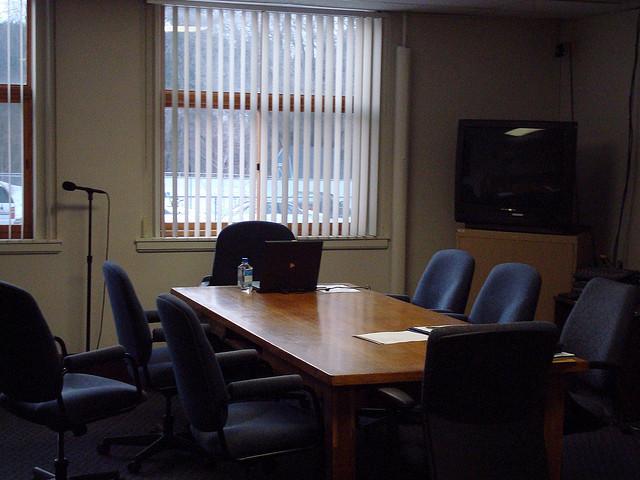How many chairs are there?
Answer briefly. 8. What electronic device is on the desk?
Write a very short answer. Laptop. How many chairs?
Answer briefly. 8. How many seats are there?
Concise answer only. 8. Is this a living room?
Keep it brief. No. Is there a microphone in the room?
Give a very brief answer. Yes. What color is the laptop?
Concise answer only. Black. 